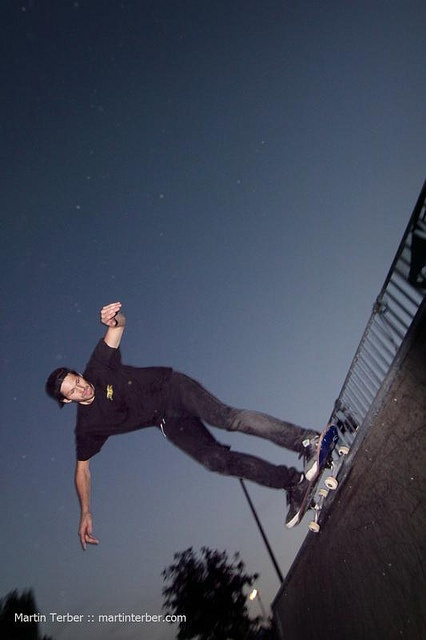Describe the objects in this image and their specific colors. I can see people in black, gray, and lightpink tones, skateboard in black, gray, and navy tones, and skateboard in black, gray, darkgray, and lightgray tones in this image. 